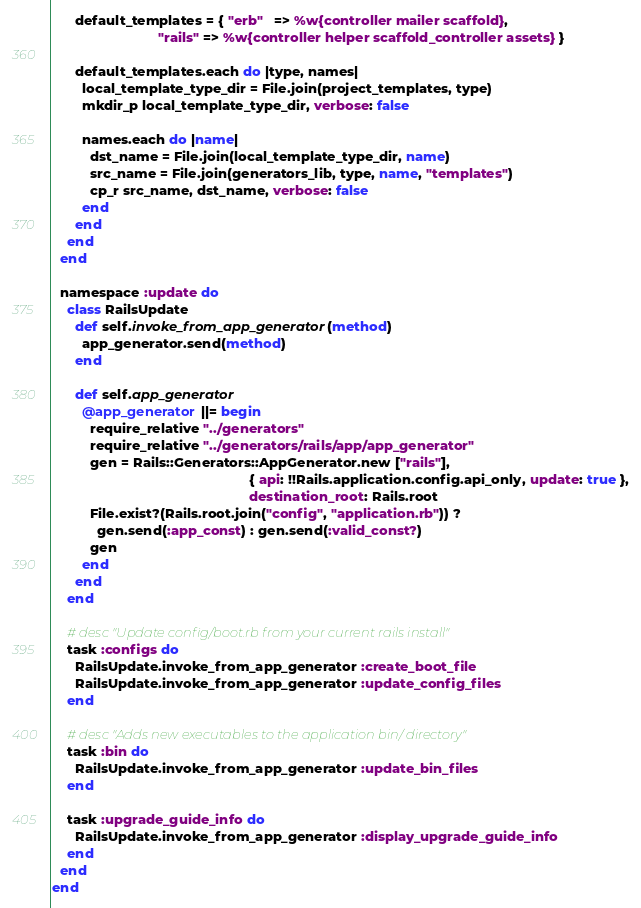<code> <loc_0><loc_0><loc_500><loc_500><_Ruby_>
      default_templates = { "erb"   => %w{controller mailer scaffold},
                            "rails" => %w{controller helper scaffold_controller assets} }

      default_templates.each do |type, names|
        local_template_type_dir = File.join(project_templates, type)
        mkdir_p local_template_type_dir, verbose: false

        names.each do |name|
          dst_name = File.join(local_template_type_dir, name)
          src_name = File.join(generators_lib, type, name, "templates")
          cp_r src_name, dst_name, verbose: false
        end
      end
    end
  end

  namespace :update do
    class RailsUpdate
      def self.invoke_from_app_generator(method)
        app_generator.send(method)
      end

      def self.app_generator
        @app_generator ||= begin
          require_relative "../generators"
          require_relative "../generators/rails/app/app_generator"
          gen = Rails::Generators::AppGenerator.new ["rails"],
                                                    { api: !!Rails.application.config.api_only, update: true },
                                                    destination_root: Rails.root
          File.exist?(Rails.root.join("config", "application.rb")) ?
            gen.send(:app_const) : gen.send(:valid_const?)
          gen
        end
      end
    end

    # desc "Update config/boot.rb from your current rails install"
    task :configs do
      RailsUpdate.invoke_from_app_generator :create_boot_file
      RailsUpdate.invoke_from_app_generator :update_config_files
    end

    # desc "Adds new executables to the application bin/ directory"
    task :bin do
      RailsUpdate.invoke_from_app_generator :update_bin_files
    end

    task :upgrade_guide_info do
      RailsUpdate.invoke_from_app_generator :display_upgrade_guide_info
    end
  end
end
</code> 